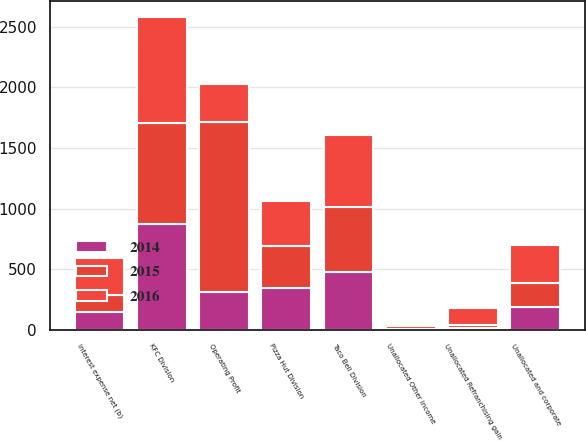Convert chart. <chart><loc_0><loc_0><loc_500><loc_500><stacked_bar_chart><ecel><fcel>KFC Division<fcel>Pizza Hut Division<fcel>Taco Bell Division<fcel>Unallocated and corporate<fcel>Unallocated Refranchising gain<fcel>Unallocated Other income<fcel>Operating Profit<fcel>Interest expense net (b)<nl><fcel>2016<fcel>874<fcel>370<fcel>593<fcel>316<fcel>141<fcel>11<fcel>311.5<fcel>307<nl><fcel>2015<fcel>832<fcel>347<fcel>536<fcel>196<fcel>23<fcel>23<fcel>1402<fcel>141<nl><fcel>2014<fcel>876<fcel>347<fcel>478<fcel>189<fcel>16<fcel>10<fcel>311.5<fcel>143<nl></chart> 